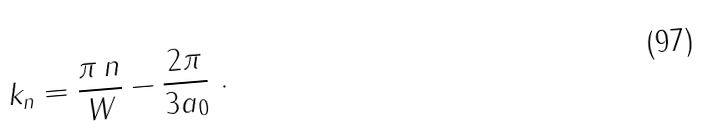<formula> <loc_0><loc_0><loc_500><loc_500>k _ { n } = \frac { \pi \, n } { W } - \frac { 2 \pi } { 3 a _ { 0 } } \ .</formula> 